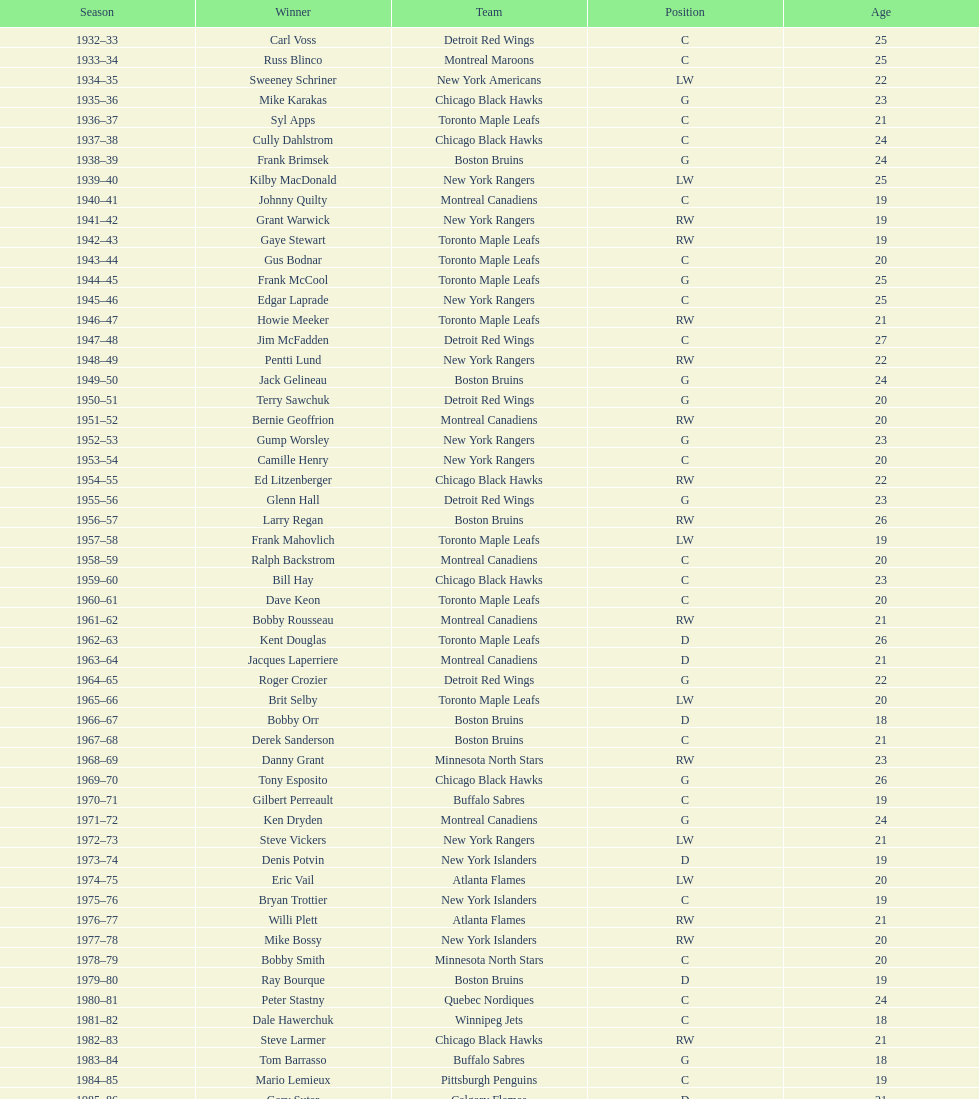Which team holds the record for the highest number of back-to-back calder memorial trophy victories? Toronto Maple Leafs. Would you be able to parse every entry in this table? {'header': ['Season', 'Winner', 'Team', 'Position', 'Age'], 'rows': [['1932–33', 'Carl Voss', 'Detroit Red Wings', 'C', '25'], ['1933–34', 'Russ Blinco', 'Montreal Maroons', 'C', '25'], ['1934–35', 'Sweeney Schriner', 'New York Americans', 'LW', '22'], ['1935–36', 'Mike Karakas', 'Chicago Black Hawks', 'G', '23'], ['1936–37', 'Syl Apps', 'Toronto Maple Leafs', 'C', '21'], ['1937–38', 'Cully Dahlstrom', 'Chicago Black Hawks', 'C', '24'], ['1938–39', 'Frank Brimsek', 'Boston Bruins', 'G', '24'], ['1939–40', 'Kilby MacDonald', 'New York Rangers', 'LW', '25'], ['1940–41', 'Johnny Quilty', 'Montreal Canadiens', 'C', '19'], ['1941–42', 'Grant Warwick', 'New York Rangers', 'RW', '19'], ['1942–43', 'Gaye Stewart', 'Toronto Maple Leafs', 'RW', '19'], ['1943–44', 'Gus Bodnar', 'Toronto Maple Leafs', 'C', '20'], ['1944–45', 'Frank McCool', 'Toronto Maple Leafs', 'G', '25'], ['1945–46', 'Edgar Laprade', 'New York Rangers', 'C', '25'], ['1946–47', 'Howie Meeker', 'Toronto Maple Leafs', 'RW', '21'], ['1947–48', 'Jim McFadden', 'Detroit Red Wings', 'C', '27'], ['1948–49', 'Pentti Lund', 'New York Rangers', 'RW', '22'], ['1949–50', 'Jack Gelineau', 'Boston Bruins', 'G', '24'], ['1950–51', 'Terry Sawchuk', 'Detroit Red Wings', 'G', '20'], ['1951–52', 'Bernie Geoffrion', 'Montreal Canadiens', 'RW', '20'], ['1952–53', 'Gump Worsley', 'New York Rangers', 'G', '23'], ['1953–54', 'Camille Henry', 'New York Rangers', 'C', '20'], ['1954–55', 'Ed Litzenberger', 'Chicago Black Hawks', 'RW', '22'], ['1955–56', 'Glenn Hall', 'Detroit Red Wings', 'G', '23'], ['1956–57', 'Larry Regan', 'Boston Bruins', 'RW', '26'], ['1957–58', 'Frank Mahovlich', 'Toronto Maple Leafs', 'LW', '19'], ['1958–59', 'Ralph Backstrom', 'Montreal Canadiens', 'C', '20'], ['1959–60', 'Bill Hay', 'Chicago Black Hawks', 'C', '23'], ['1960–61', 'Dave Keon', 'Toronto Maple Leafs', 'C', '20'], ['1961–62', 'Bobby Rousseau', 'Montreal Canadiens', 'RW', '21'], ['1962–63', 'Kent Douglas', 'Toronto Maple Leafs', 'D', '26'], ['1963–64', 'Jacques Laperriere', 'Montreal Canadiens', 'D', '21'], ['1964–65', 'Roger Crozier', 'Detroit Red Wings', 'G', '22'], ['1965–66', 'Brit Selby', 'Toronto Maple Leafs', 'LW', '20'], ['1966–67', 'Bobby Orr', 'Boston Bruins', 'D', '18'], ['1967–68', 'Derek Sanderson', 'Boston Bruins', 'C', '21'], ['1968–69', 'Danny Grant', 'Minnesota North Stars', 'RW', '23'], ['1969–70', 'Tony Esposito', 'Chicago Black Hawks', 'G', '26'], ['1970–71', 'Gilbert Perreault', 'Buffalo Sabres', 'C', '19'], ['1971–72', 'Ken Dryden', 'Montreal Canadiens', 'G', '24'], ['1972–73', 'Steve Vickers', 'New York Rangers', 'LW', '21'], ['1973–74', 'Denis Potvin', 'New York Islanders', 'D', '19'], ['1974–75', 'Eric Vail', 'Atlanta Flames', 'LW', '20'], ['1975–76', 'Bryan Trottier', 'New York Islanders', 'C', '19'], ['1976–77', 'Willi Plett', 'Atlanta Flames', 'RW', '21'], ['1977–78', 'Mike Bossy', 'New York Islanders', 'RW', '20'], ['1978–79', 'Bobby Smith', 'Minnesota North Stars', 'C', '20'], ['1979–80', 'Ray Bourque', 'Boston Bruins', 'D', '19'], ['1980–81', 'Peter Stastny', 'Quebec Nordiques', 'C', '24'], ['1981–82', 'Dale Hawerchuk', 'Winnipeg Jets', 'C', '18'], ['1982–83', 'Steve Larmer', 'Chicago Black Hawks', 'RW', '21'], ['1983–84', 'Tom Barrasso', 'Buffalo Sabres', 'G', '18'], ['1984–85', 'Mario Lemieux', 'Pittsburgh Penguins', 'C', '19'], ['1985–86', 'Gary Suter', 'Calgary Flames', 'D', '21'], ['1986–87', 'Luc Robitaille', 'Los Angeles Kings', 'LW', '20'], ['1987–88', 'Joe Nieuwendyk', 'Calgary Flames', 'C', '21'], ['1988–89', 'Brian Leetch', 'New York Rangers', 'D', '20'], ['1989–90', 'Sergei Makarov', 'Calgary Flames', 'RW', '31'], ['1990–91', 'Ed Belfour', 'Chicago Blackhawks', 'G', '25'], ['1991–92', 'Pavel Bure', 'Vancouver Canucks', 'RW', '20'], ['1992–93', 'Teemu Selanne', 'Winnipeg Jets', 'RW', '22'], ['1993–94', 'Martin Brodeur', 'New Jersey Devils', 'G', '21'], ['1994–95', 'Peter Forsberg', 'Quebec Nordiques', 'C', '21'], ['1995–96', 'Daniel Alfredsson', 'Ottawa Senators', 'RW', '22'], ['1996–97', 'Bryan Berard', 'New York Islanders', 'D', '19'], ['1997–98', 'Sergei Samsonov', 'Boston Bruins', 'LW', '19'], ['1998–99', 'Chris Drury', 'Colorado Avalanche', 'C', '22'], ['1999–2000', 'Scott Gomez', 'New Jersey Devils', 'C', '19'], ['2000–01', 'Evgeni Nabokov', 'San Jose Sharks', 'G', '25'], ['2001–02', 'Dany Heatley', 'Atlanta Thrashers', 'RW', '20'], ['2002–03', 'Barret Jackman', 'St. Louis Blues', 'D', '21'], ['2003–04', 'Andrew Raycroft', 'Boston Bruins', 'G', '23'], ['2004–05', 'No winner because of the\\n2004–05 NHL lockout', '-', '-', '-'], ['2005–06', 'Alexander Ovechkin', 'Washington Capitals', 'LW', '20'], ['2006–07', 'Evgeni Malkin', 'Pittsburgh Penguins', 'C', '20'], ['2007–08', 'Patrick Kane', 'Chicago Blackhawks', 'RW', '19'], ['2008–09', 'Steve Mason', 'Columbus Blue Jackets', 'G', '21'], ['2009–10', 'Tyler Myers', 'Buffalo Sabres', 'D', '20'], ['2010–11', 'Jeff Skinner', 'Carolina Hurricanes', 'C', '18'], ['2011–12', 'Gabriel Landeskog', 'Colorado Avalanche', 'LW', '19'], ['2012–13', 'Jonathan Huberdeau', 'Florida Panthers', 'C', '19']]} 